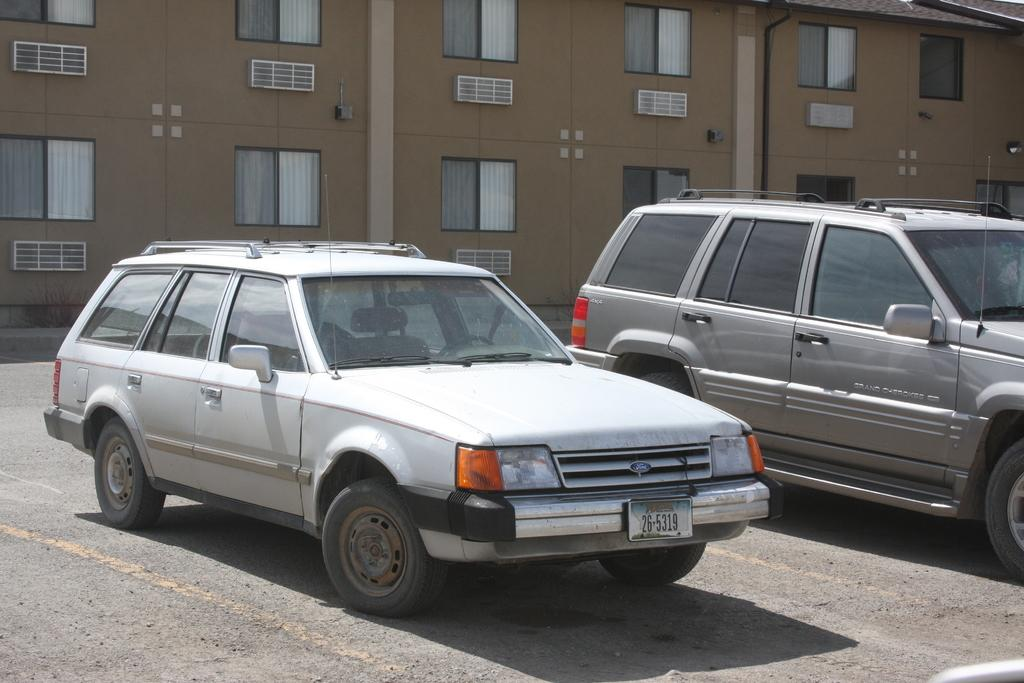What types of objects can be seen in the image? There are vehicles in the image. What can be seen beneath the vehicles? The ground is visible in the image. What structure is present in the image? There is a building with windows in the image. What type of window treatment is present on the windows of the building? Curtains are present on the windows of the building. What can be seen attached to the wall of the building? There are objects attached to the wall of the building. Can you tell me how many fowl are perched on the roof of the building in the image? There are no fowl present in the image; it only features vehicles, the ground, a building with windows, curtains, and objects attached to the wall. Is there a volcano visible in the background of the image? There is no volcano present in the image. 